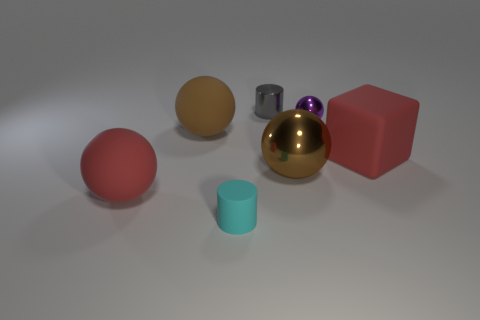Add 1 brown metal objects. How many objects exist? 8 Subtract all balls. How many objects are left? 3 Add 7 small blocks. How many small blocks exist? 7 Subtract 1 purple spheres. How many objects are left? 6 Subtract all red matte balls. Subtract all gray metal things. How many objects are left? 5 Add 4 cylinders. How many cylinders are left? 6 